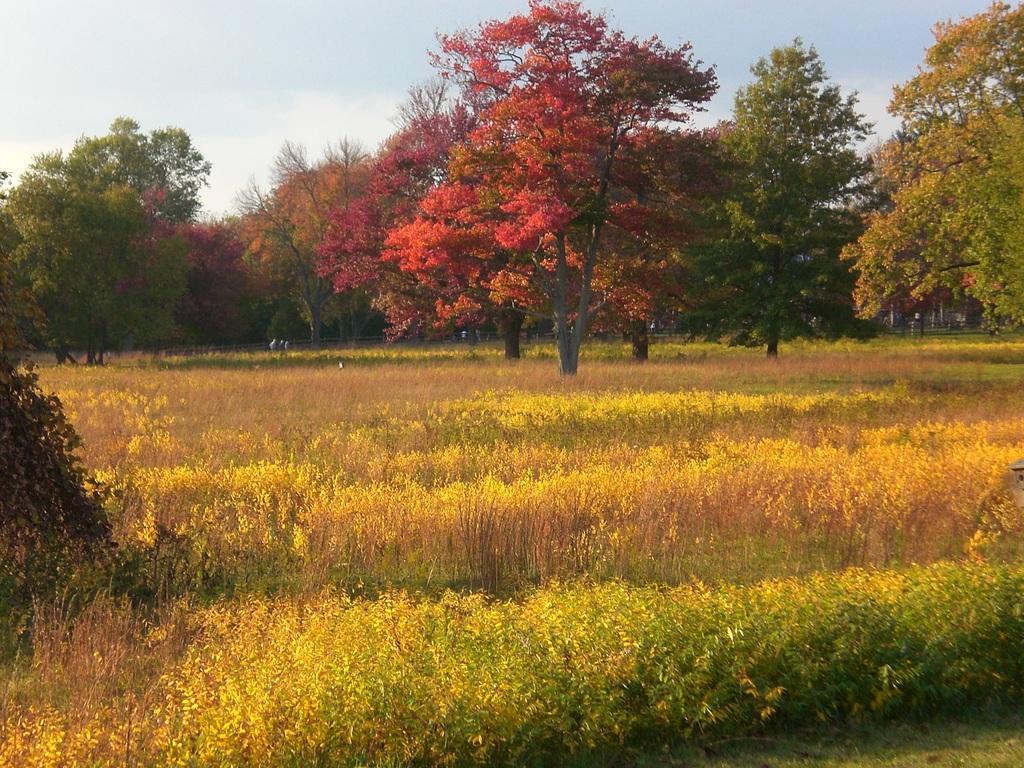Could you give a brief overview of what you see in this image? In this image, we can see some grass and plants. There are a few trees and some objects. We can see the sky. 